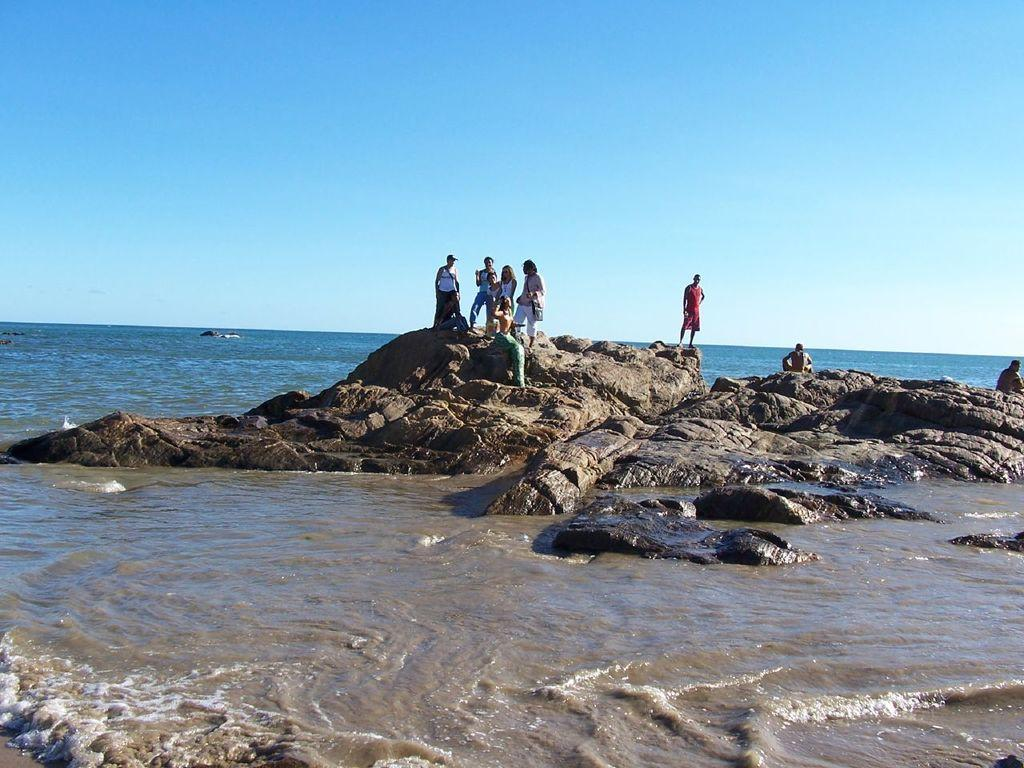What is the primary element present in the image? There is water in the image. Are there any living beings visible in the image? Yes, there are people in the image. What type of natural formation can be seen in the image? There are rocks in the image. What is visible in the background of the image? The sky is visible in the image. What type of instrument is the dad playing in the image? There is no dad or instrument present in the image. 